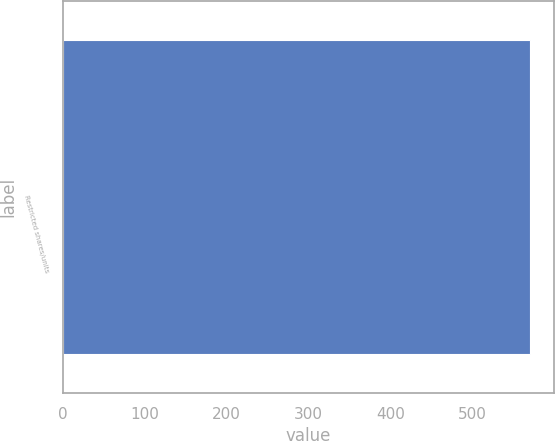<chart> <loc_0><loc_0><loc_500><loc_500><bar_chart><fcel>Restricted shares/units<nl><fcel>571<nl></chart> 